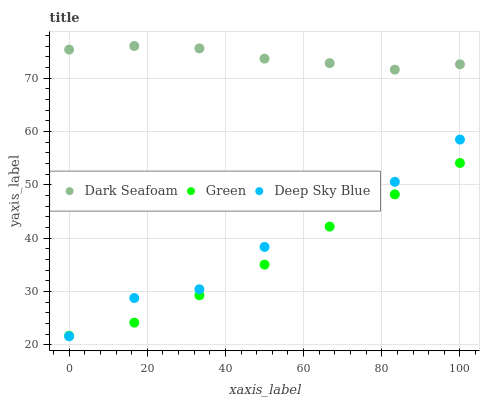Does Green have the minimum area under the curve?
Answer yes or no. Yes. Does Dark Seafoam have the maximum area under the curve?
Answer yes or no. Yes. Does Deep Sky Blue have the minimum area under the curve?
Answer yes or no. No. Does Deep Sky Blue have the maximum area under the curve?
Answer yes or no. No. Is Green the smoothest?
Answer yes or no. Yes. Is Deep Sky Blue the roughest?
Answer yes or no. Yes. Is Deep Sky Blue the smoothest?
Answer yes or no. No. Is Green the roughest?
Answer yes or no. No. Does Deep Sky Blue have the lowest value?
Answer yes or no. Yes. Does Green have the lowest value?
Answer yes or no. No. Does Dark Seafoam have the highest value?
Answer yes or no. Yes. Does Deep Sky Blue have the highest value?
Answer yes or no. No. Is Green less than Dark Seafoam?
Answer yes or no. Yes. Is Dark Seafoam greater than Deep Sky Blue?
Answer yes or no. Yes. Does Deep Sky Blue intersect Green?
Answer yes or no. Yes. Is Deep Sky Blue less than Green?
Answer yes or no. No. Is Deep Sky Blue greater than Green?
Answer yes or no. No. Does Green intersect Dark Seafoam?
Answer yes or no. No. 